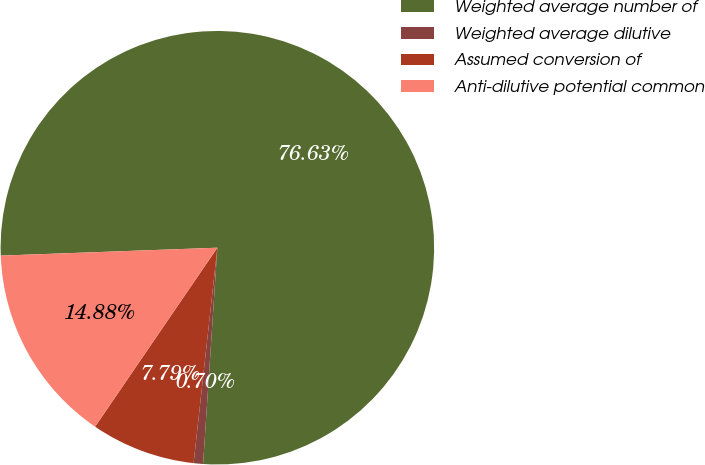Convert chart to OTSL. <chart><loc_0><loc_0><loc_500><loc_500><pie_chart><fcel>Weighted average number of<fcel>Weighted average dilutive<fcel>Assumed conversion of<fcel>Anti-dilutive potential common<nl><fcel>76.63%<fcel>0.7%<fcel>7.79%<fcel>14.88%<nl></chart> 